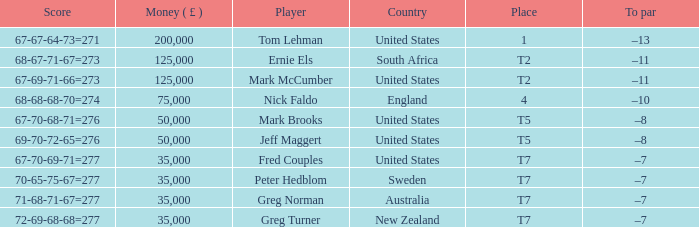What is Score, when Country is "United States", and when Player is "Mark Brooks"? 67-70-68-71=276. 